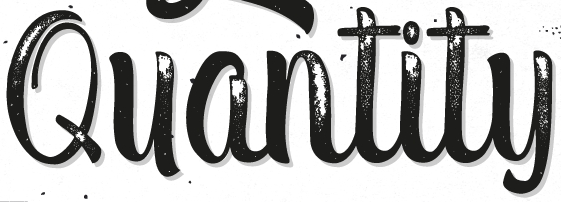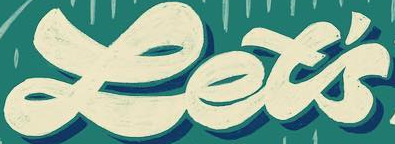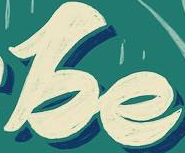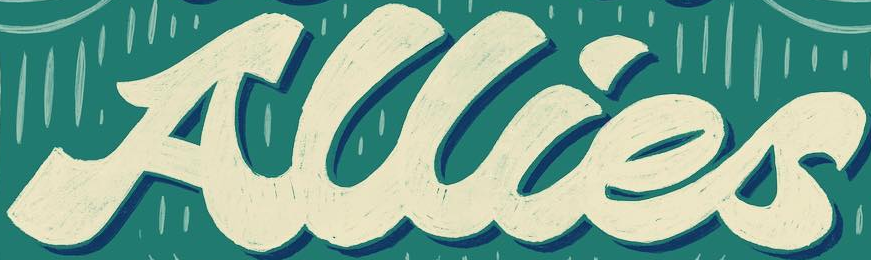What text appears in these images from left to right, separated by a semicolon? Quantity; Let's; be; Allies 